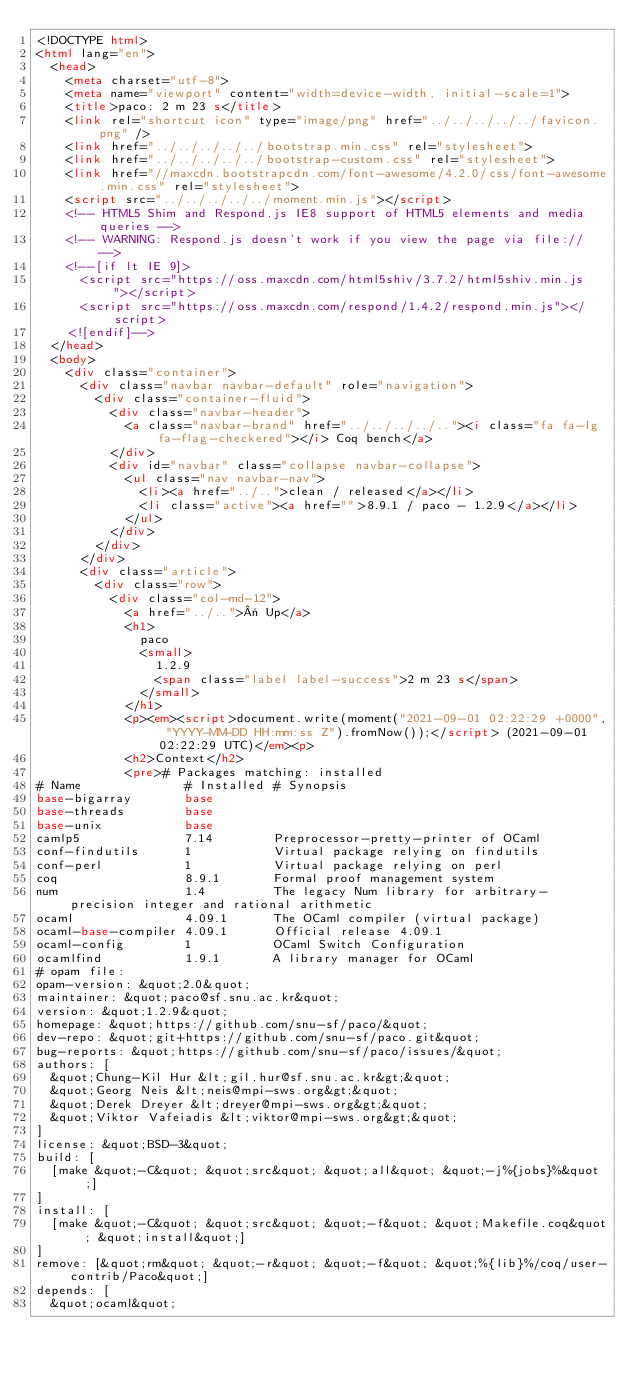<code> <loc_0><loc_0><loc_500><loc_500><_HTML_><!DOCTYPE html>
<html lang="en">
  <head>
    <meta charset="utf-8">
    <meta name="viewport" content="width=device-width, initial-scale=1">
    <title>paco: 2 m 23 s</title>
    <link rel="shortcut icon" type="image/png" href="../../../../../favicon.png" />
    <link href="../../../../../bootstrap.min.css" rel="stylesheet">
    <link href="../../../../../bootstrap-custom.css" rel="stylesheet">
    <link href="//maxcdn.bootstrapcdn.com/font-awesome/4.2.0/css/font-awesome.min.css" rel="stylesheet">
    <script src="../../../../../moment.min.js"></script>
    <!-- HTML5 Shim and Respond.js IE8 support of HTML5 elements and media queries -->
    <!-- WARNING: Respond.js doesn't work if you view the page via file:// -->
    <!--[if lt IE 9]>
      <script src="https://oss.maxcdn.com/html5shiv/3.7.2/html5shiv.min.js"></script>
      <script src="https://oss.maxcdn.com/respond/1.4.2/respond.min.js"></script>
    <![endif]-->
  </head>
  <body>
    <div class="container">
      <div class="navbar navbar-default" role="navigation">
        <div class="container-fluid">
          <div class="navbar-header">
            <a class="navbar-brand" href="../../../../.."><i class="fa fa-lg fa-flag-checkered"></i> Coq bench</a>
          </div>
          <div id="navbar" class="collapse navbar-collapse">
            <ul class="nav navbar-nav">
              <li><a href="../..">clean / released</a></li>
              <li class="active"><a href="">8.9.1 / paco - 1.2.9</a></li>
            </ul>
          </div>
        </div>
      </div>
      <div class="article">
        <div class="row">
          <div class="col-md-12">
            <a href="../..">« Up</a>
            <h1>
              paco
              <small>
                1.2.9
                <span class="label label-success">2 m 23 s</span>
              </small>
            </h1>
            <p><em><script>document.write(moment("2021-09-01 02:22:29 +0000", "YYYY-MM-DD HH:mm:ss Z").fromNow());</script> (2021-09-01 02:22:29 UTC)</em><p>
            <h2>Context</h2>
            <pre># Packages matching: installed
# Name              # Installed # Synopsis
base-bigarray       base
base-threads        base
base-unix           base
camlp5              7.14        Preprocessor-pretty-printer of OCaml
conf-findutils      1           Virtual package relying on findutils
conf-perl           1           Virtual package relying on perl
coq                 8.9.1       Formal proof management system
num                 1.4         The legacy Num library for arbitrary-precision integer and rational arithmetic
ocaml               4.09.1      The OCaml compiler (virtual package)
ocaml-base-compiler 4.09.1      Official release 4.09.1
ocaml-config        1           OCaml Switch Configuration
ocamlfind           1.9.1       A library manager for OCaml
# opam file:
opam-version: &quot;2.0&quot;
maintainer: &quot;paco@sf.snu.ac.kr&quot;
version: &quot;1.2.9&quot;
homepage: &quot;https://github.com/snu-sf/paco/&quot;
dev-repo: &quot;git+https://github.com/snu-sf/paco.git&quot;
bug-reports: &quot;https://github.com/snu-sf/paco/issues/&quot;
authors: [
  &quot;Chung-Kil Hur &lt;gil.hur@sf.snu.ac.kr&gt;&quot;
  &quot;Georg Neis &lt;neis@mpi-sws.org&gt;&quot;
  &quot;Derek Dreyer &lt;dreyer@mpi-sws.org&gt;&quot;
  &quot;Viktor Vafeiadis &lt;viktor@mpi-sws.org&gt;&quot;
]
license: &quot;BSD-3&quot;
build: [
  [make &quot;-C&quot; &quot;src&quot; &quot;all&quot; &quot;-j%{jobs}%&quot;]
]
install: [
  [make &quot;-C&quot; &quot;src&quot; &quot;-f&quot; &quot;Makefile.coq&quot; &quot;install&quot;]
]
remove: [&quot;rm&quot; &quot;-r&quot; &quot;-f&quot; &quot;%{lib}%/coq/user-contrib/Paco&quot;]
depends: [
  &quot;ocaml&quot;</code> 